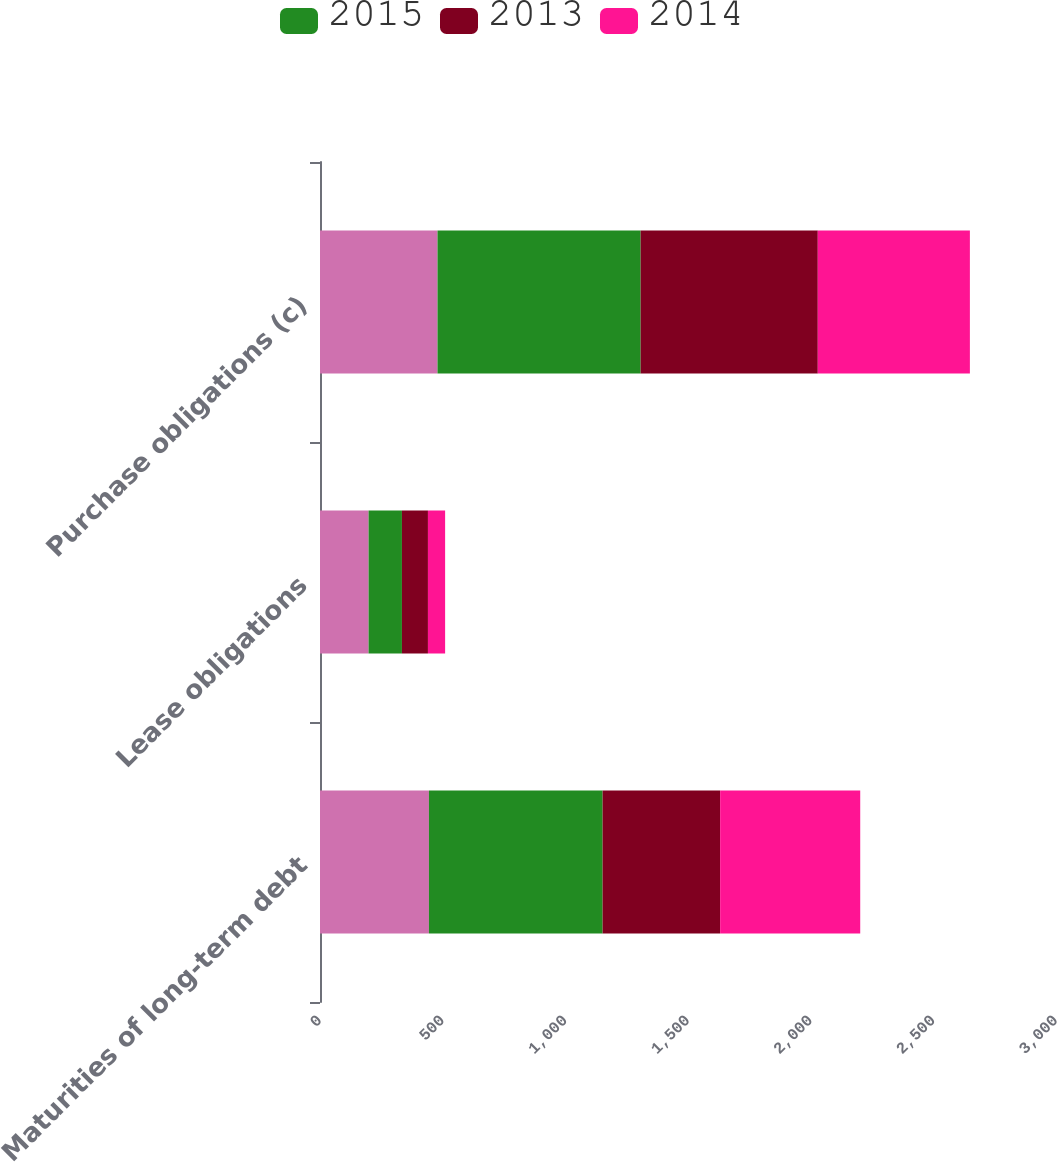Convert chart. <chart><loc_0><loc_0><loc_500><loc_500><stacked_bar_chart><ecel><fcel>Maturities of long-term debt<fcel>Lease obligations<fcel>Purchase obligations (c)<nl><fcel>nan<fcel>444<fcel>198<fcel>479<nl><fcel>2015<fcel>708<fcel>136<fcel>828<nl><fcel>2013<fcel>479<fcel>106<fcel>722<nl><fcel>2014<fcel>571<fcel>70<fcel>620<nl></chart> 